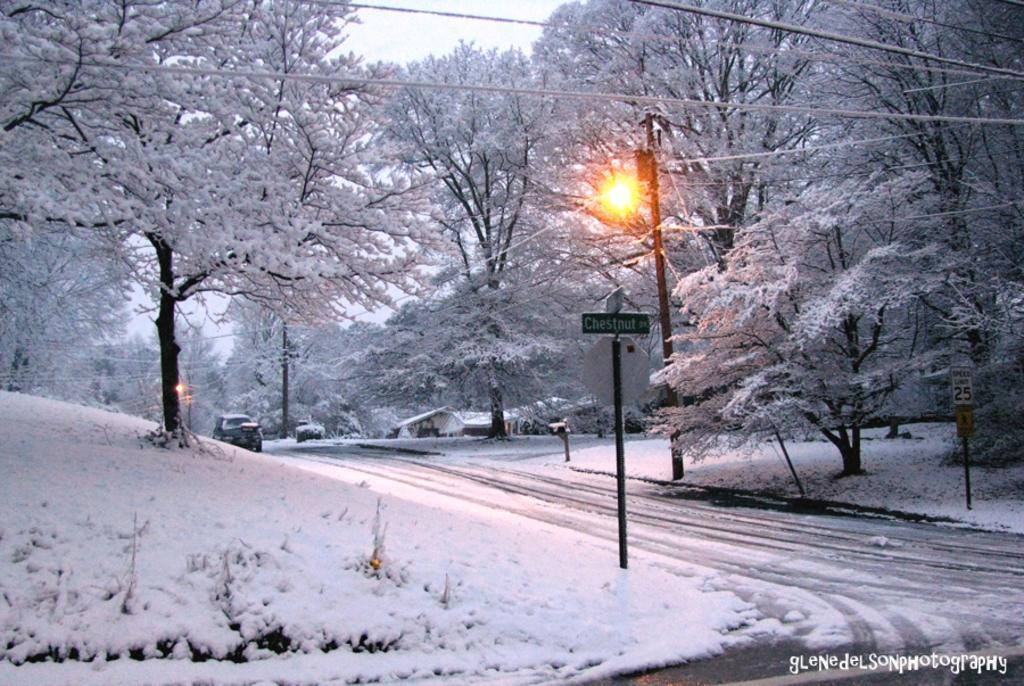Describe this image in one or two sentences. In this image we can see trees, street poles, street lights, electric cables, name boards, road and all are covered with snow. In the background there is sky. 